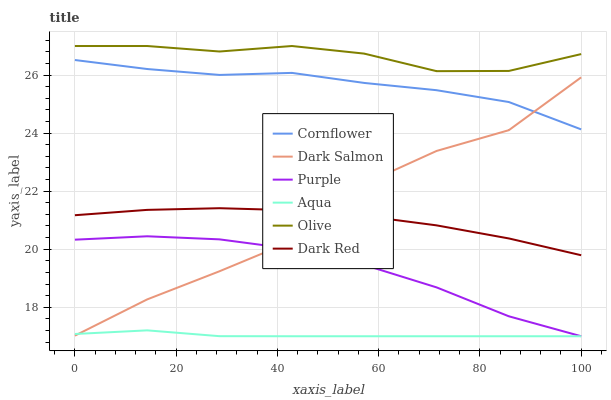Does Aqua have the minimum area under the curve?
Answer yes or no. Yes. Does Olive have the maximum area under the curve?
Answer yes or no. Yes. Does Purple have the minimum area under the curve?
Answer yes or no. No. Does Purple have the maximum area under the curve?
Answer yes or no. No. Is Aqua the smoothest?
Answer yes or no. Yes. Is Dark Salmon the roughest?
Answer yes or no. Yes. Is Purple the smoothest?
Answer yes or no. No. Is Purple the roughest?
Answer yes or no. No. Does Purple have the lowest value?
Answer yes or no. Yes. Does Dark Red have the lowest value?
Answer yes or no. No. Does Olive have the highest value?
Answer yes or no. Yes. Does Purple have the highest value?
Answer yes or no. No. Is Aqua less than Cornflower?
Answer yes or no. Yes. Is Cornflower greater than Dark Red?
Answer yes or no. Yes. Does Aqua intersect Dark Salmon?
Answer yes or no. Yes. Is Aqua less than Dark Salmon?
Answer yes or no. No. Is Aqua greater than Dark Salmon?
Answer yes or no. No. Does Aqua intersect Cornflower?
Answer yes or no. No. 